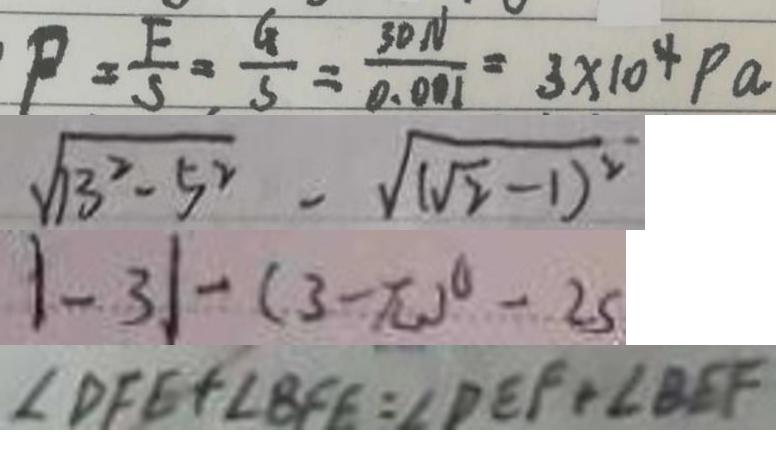<formula> <loc_0><loc_0><loc_500><loc_500>P = \frac { F } { S } = \frac { G } { S } = \frac { 3 0 N } { 0 . 0 0 1 } = 3 \times 1 0 ^ { 4 } P a 
 \sqrt { 1 3 ^ { 2 } - 5 ^ { 2 } } - \sqrt { ( \sqrt { 2 } - 1 ) ^ { 2 } } 
 \vert - 3 \vert - ( 3 - \pi ) ^ { 0 } - 2 5 
 \angle D F E + \angle B F E = \angle D E F + \angle B E F</formula> 